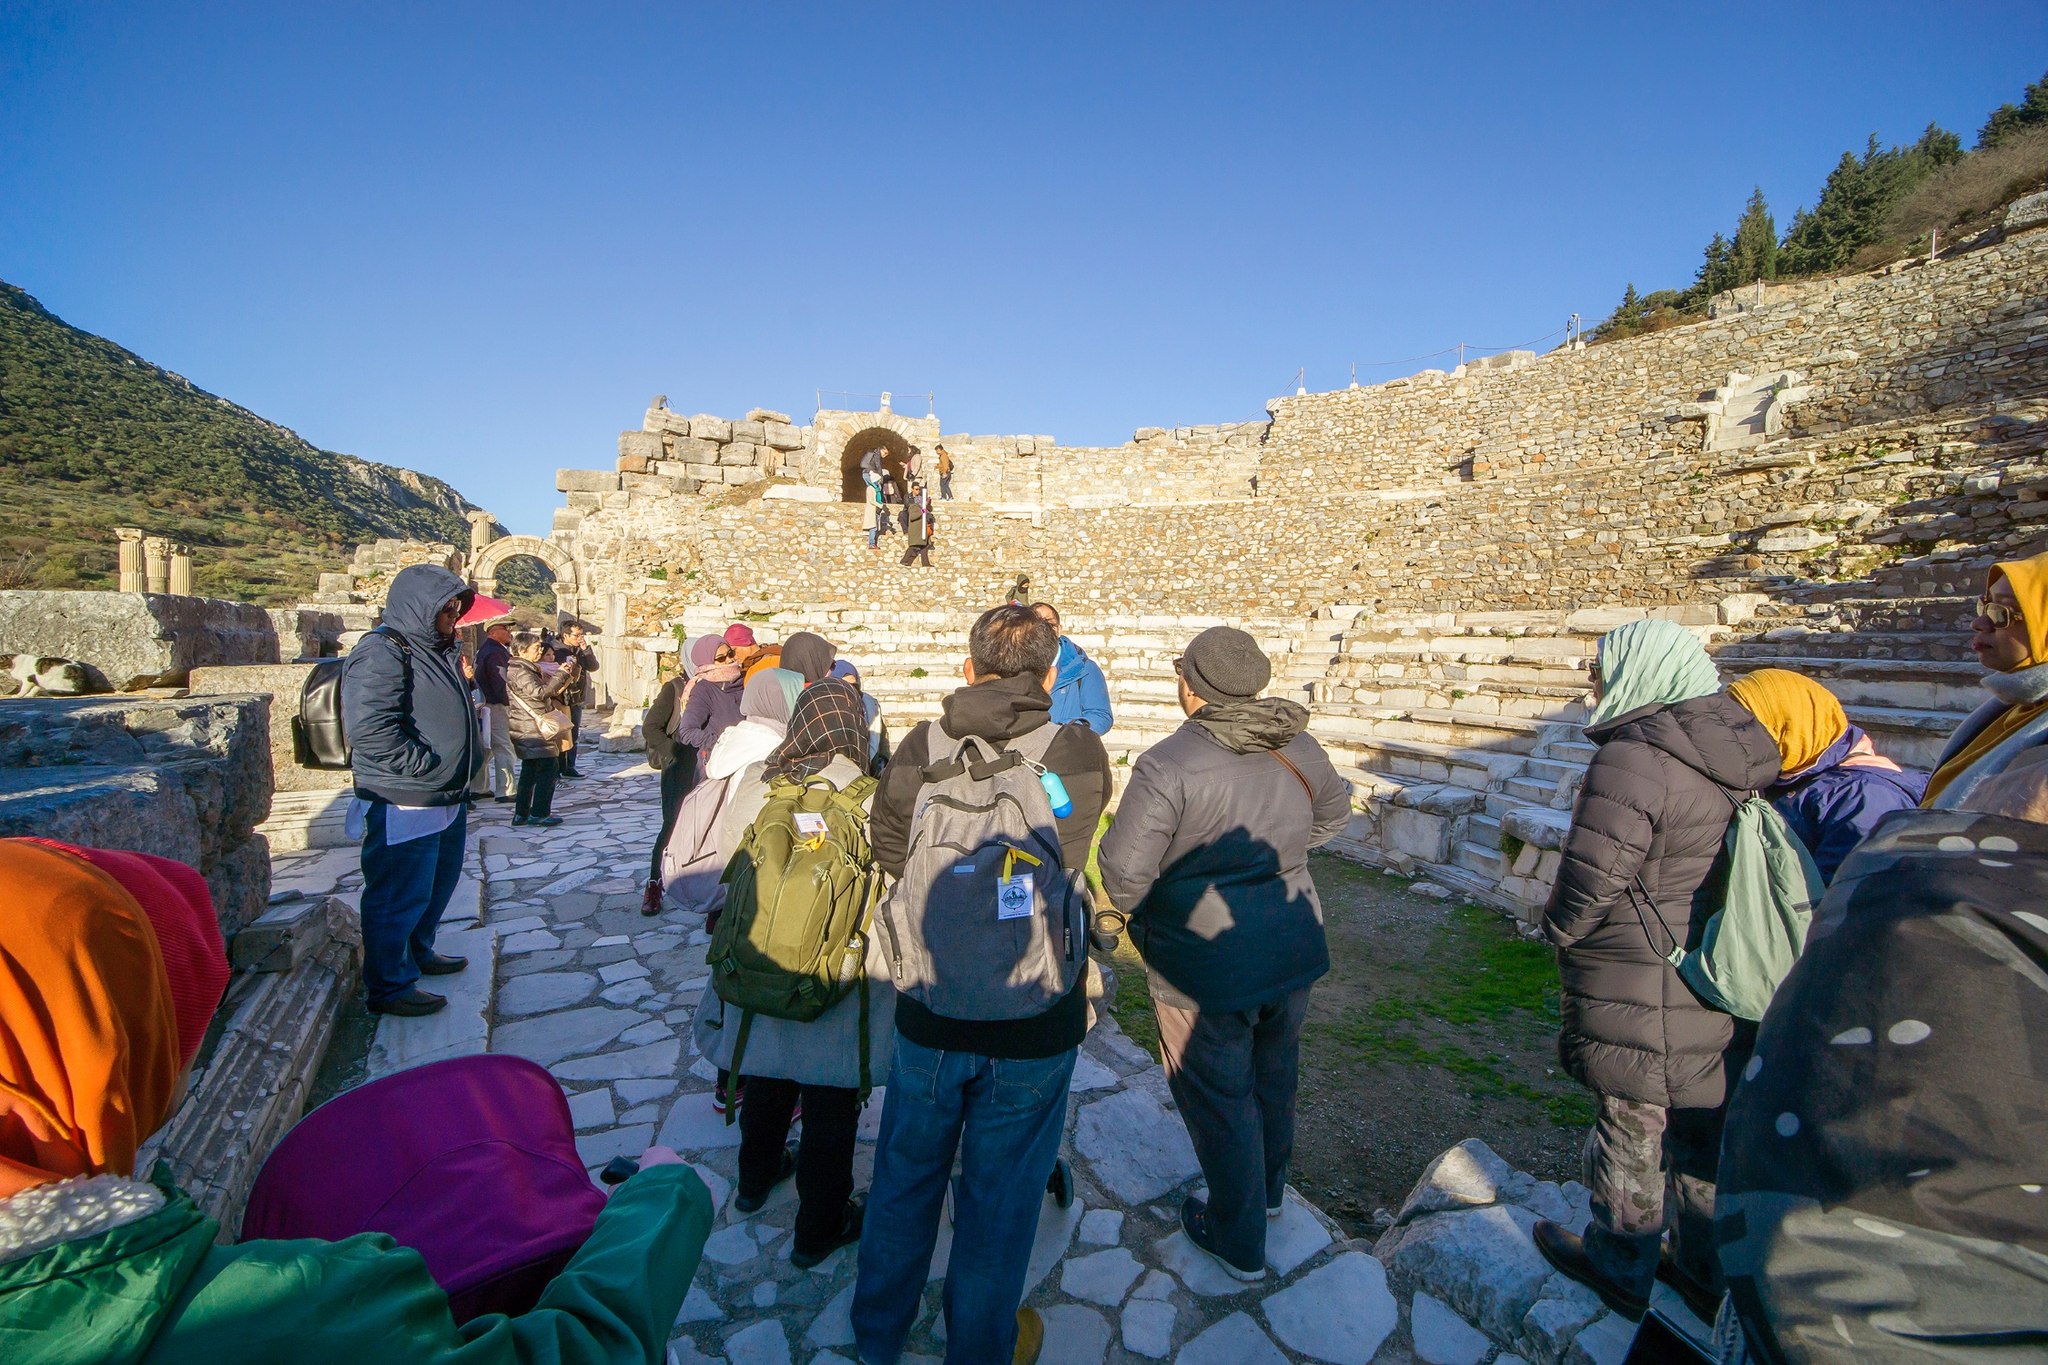Imagine if these ruins could talk. What stories would they tell us? If these ruins could talk, they would recount tales of the vibrant activities that once took place here. They might describe the bustling markets, where merchants traded goods and exchanged news. The amphitheater steps would echo with the footsteps of citizens gathering for public debates, watching performances, or listening to announcements from their leaders. The archway might have stories of grand processions, welcoming dignitaries, or marking the start of important celebrations. Through the walls and pathways, we’d learn about the daily lives of people, their triumphs, struggles, and the rich tapestry of events that shaped the history of this site. These silent stones, having stood the test of time, would share their wisdom and the enduring legacy of a bygone era. Could you create a poem inspired by this image? Among the ancient stones we tread,
Where whispers of the past are led.
Archways stand in silent grace,
Guardians of this hallowed space.

Footsteps of the curious blend,
With echoes time will never end.
Stories of old, wrapped in the breeze,
In history’s folds, whispers seize.

Mountains rise, as shadows play,
In the sunlight’s warm embrace they lay.
Silent ruins tell of yore,
In every brick, a tale of lore.

Tourists roam in reverent awe,
Through pathways where great feet once saw.
A timeless dance, the old and new,
In this ancient site, forever true. 